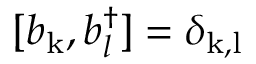<formula> <loc_0><loc_0><loc_500><loc_500>[ b _ { k } , b _ { l } ^ { \dagger } ] = \delta _ { k , l }</formula> 